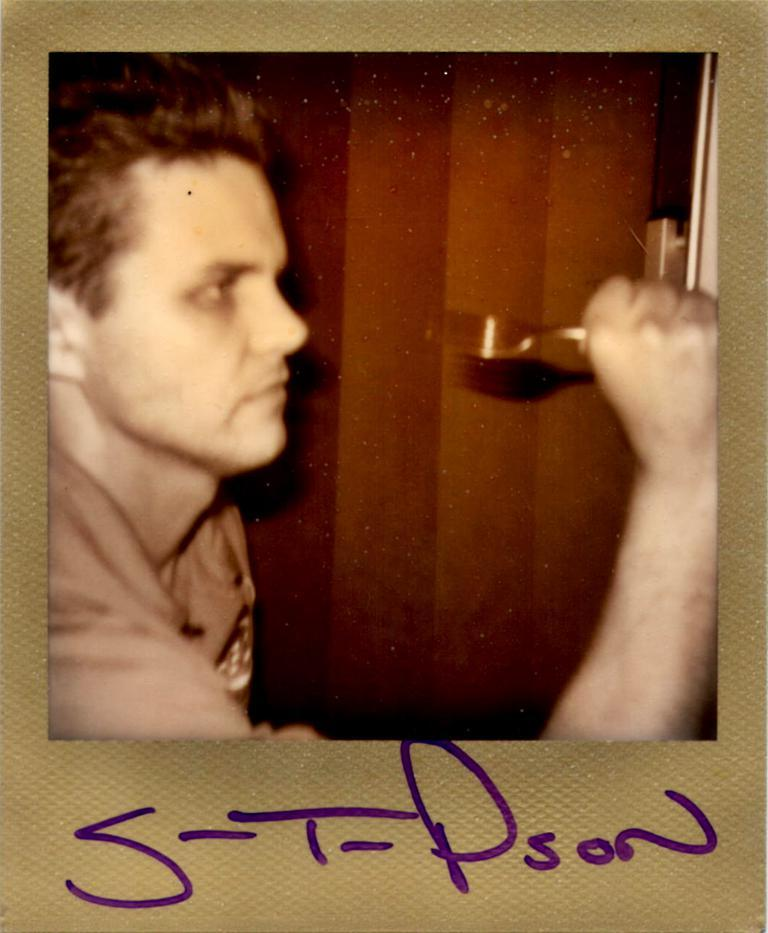What is the person in the image holding? The person in the image is holding a fork. Is there any text or writing present in the image? Yes, there is text or writing at the bottom of the image. Can you see any ghosts interacting with the person holding the fork in the image? No, there are no ghosts present in the image. 